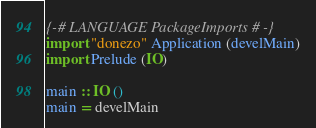Convert code to text. <code><loc_0><loc_0><loc_500><loc_500><_Haskell_>{-# LANGUAGE PackageImports #-}
import "donezo" Application (develMain)
import Prelude (IO)

main :: IO ()
main = develMain
</code> 